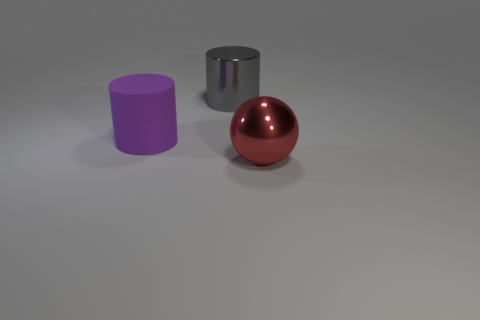Add 3 gray shiny spheres. How many objects exist? 6 Subtract all cylinders. How many objects are left? 1 Add 2 purple cylinders. How many purple cylinders are left? 3 Add 3 small matte objects. How many small matte objects exist? 3 Subtract 0 blue spheres. How many objects are left? 3 Subtract all small green blocks. Subtract all large red balls. How many objects are left? 2 